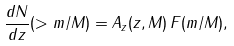<formula> <loc_0><loc_0><loc_500><loc_500>\frac { d N } { d z } ( > m / M ) = A _ { z } ( z , M ) \, F ( m / M ) ,</formula> 